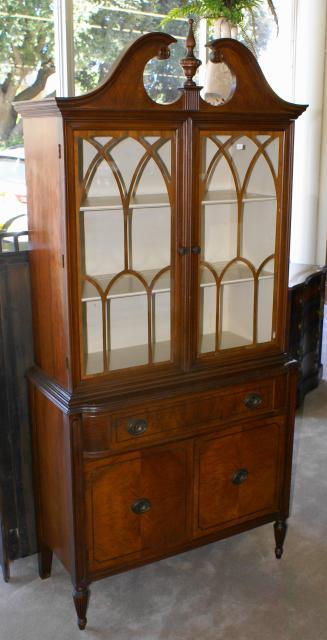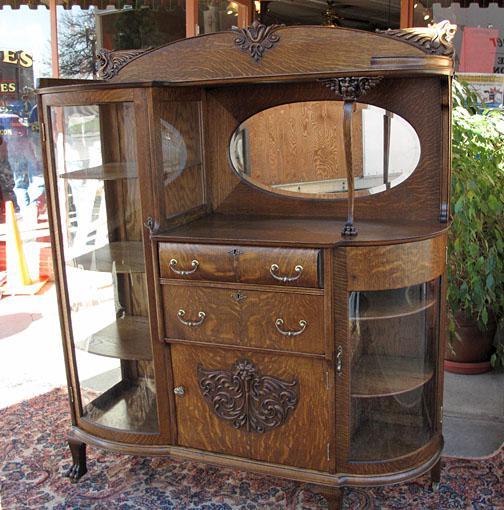The first image is the image on the left, the second image is the image on the right. For the images shown, is this caption "All the cabinets have legs." true? Answer yes or no. Yes. 